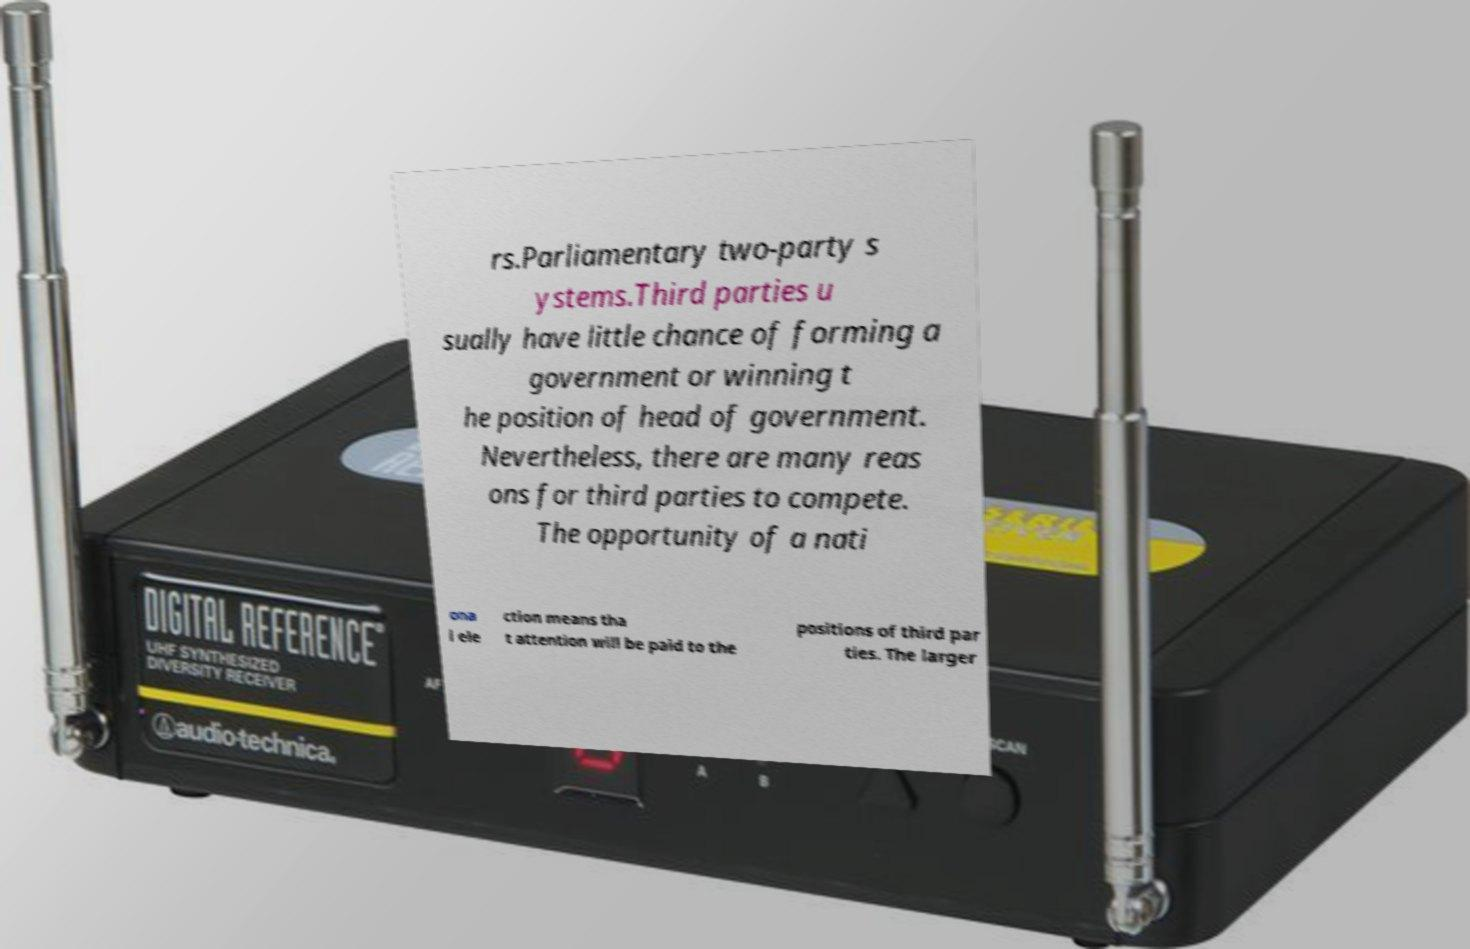What messages or text are displayed in this image? I need them in a readable, typed format. rs.Parliamentary two-party s ystems.Third parties u sually have little chance of forming a government or winning t he position of head of government. Nevertheless, there are many reas ons for third parties to compete. The opportunity of a nati ona l ele ction means tha t attention will be paid to the positions of third par ties. The larger 